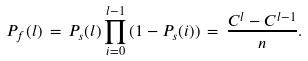Convert formula to latex. <formula><loc_0><loc_0><loc_500><loc_500>P _ { f } ( l ) \, = \, P _ { s } ( l ) \prod _ { i = 0 } ^ { l - 1 } { ( 1 - P _ { s } ( i ) ) } \, = \, \frac { C ^ { l } - C ^ { l - 1 } } { n } .</formula> 